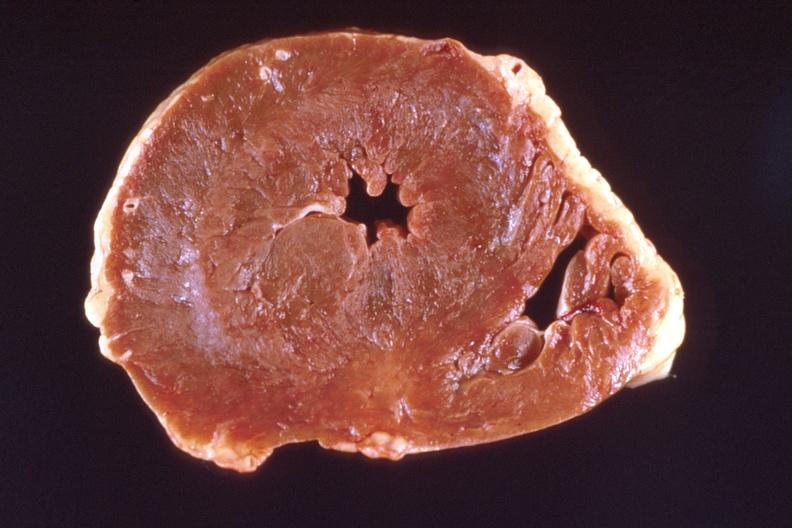what is heart , marked left?
Answer the question using a single word or phrase. Ventricular hypertrophy 